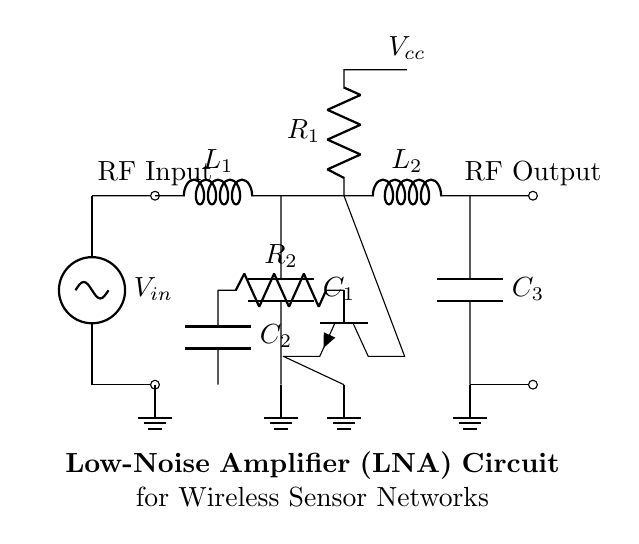What is the type of this circuit? This circuit is a Low-Noise Amplifier (LNA), which is indicated in the title at the bottom of the diagram. It focuses on maximizing gain while minimizing the added noise in wireless signal reception.
Answer: Low-Noise Amplifier How many inductors are in the circuit? There are two inductors in this circuit. They are represented as L1 and L2 and can be identified by their labeled symbols in the matching and output sections.
Answer: 2 What is the function of C1? C1 is a capacitor that, together with L1, forms a matching network to couple the RF input signal, optimizing the impedance for maximum power transfer. Its placement directly after L1 indicates its role in tuning.
Answer: Matching What does R1 connect to? R1 connects to the collector of the transistor Q1 and also to Vcc, which is the supply voltage in this circuit. This connection is important for providing the necessary biasing for the transistor's operation.
Answer: Vcc What is the role of the transistor in this circuit? The transistor Q1 acts as the amplifying component of the circuit, increasing the strength of the incoming RF signal while adding minimal noise to the output, characteristic of LNAs designed for wireless sensor applications.
Answer: Amplifier What happens to the signal at the output? The RF output signal, which has been amplified by the circuit, is fed through L2 and C3, ensuring it's properly matched for optimal power transfer to the next stage or antenna. The circuit enhances the original weak signal for better reception.
Answer: Amplified What does the ground indicate in the circuit? The ground symbol indicates the reference point for the circuit's voltage levels. It serves as a return path for current and helps stabilize the voltage levels across different components in the circuit.
Answer: Reference Point 